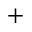Convert formula to latex. <formula><loc_0><loc_0><loc_500><loc_500>^ { + }</formula> 